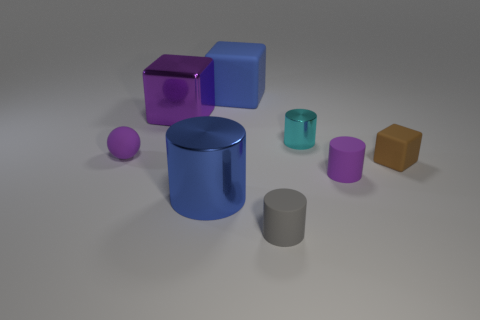How many objects are tiny brown cubes or cubes?
Keep it short and to the point. 3. Do the matte cube left of the small cyan metallic cylinder and the cube that is in front of the big purple object have the same color?
Your response must be concise. No. There is a brown rubber object that is the same size as the gray cylinder; what is its shape?
Offer a terse response. Cube. How many objects are things that are in front of the tiny cyan object or purple rubber things right of the small gray object?
Your answer should be very brief. 5. Are there fewer gray cylinders than things?
Offer a terse response. Yes. What is the material of the cyan cylinder that is the same size as the ball?
Give a very brief answer. Metal. Does the blue thing in front of the blue rubber cube have the same size as the shiny cylinder right of the blue cube?
Make the answer very short. No. Are there any big blue cubes made of the same material as the small sphere?
Make the answer very short. Yes. What number of things are either tiny objects behind the gray matte thing or large red spheres?
Offer a very short reply. 4. Are the small object left of the big purple shiny block and the brown thing made of the same material?
Your response must be concise. Yes. 